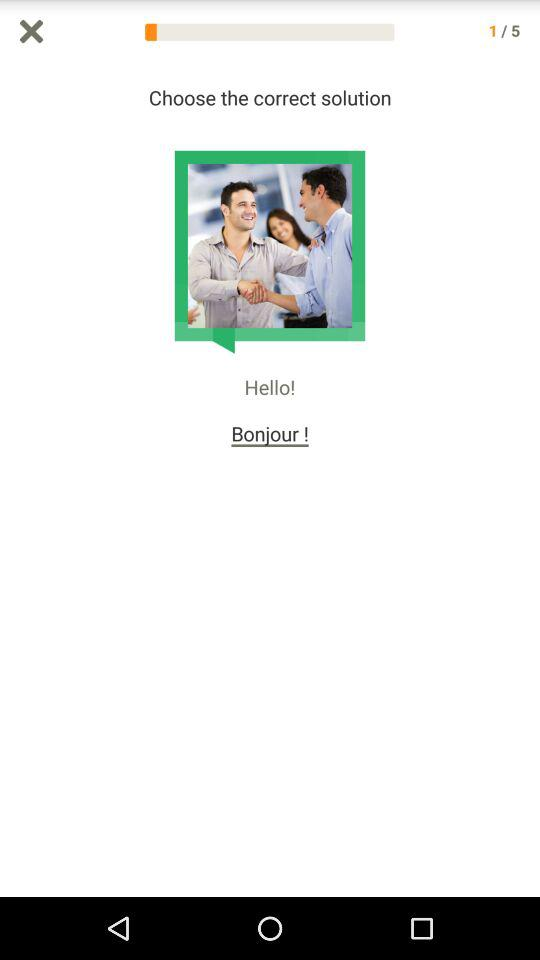How many options are there that are related to travel?
Answer the question using a single word or phrase. 1 